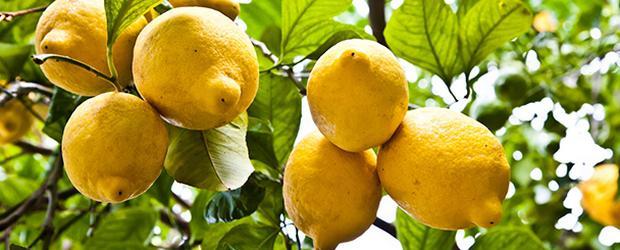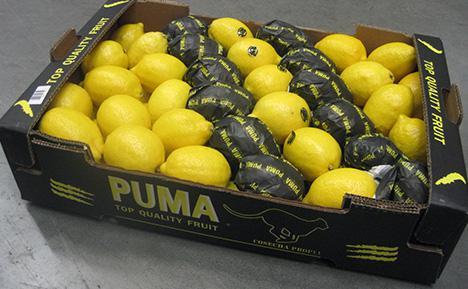The first image is the image on the left, the second image is the image on the right. Given the left and right images, does the statement "In at least one image there is a a cardboard box holding at least 6 rows of wrapped and unwrapped lemon." hold true? Answer yes or no. Yes. The first image is the image on the left, the second image is the image on the right. Examine the images to the left and right. Is the description "There are lemons inside a box." accurate? Answer yes or no. Yes. 